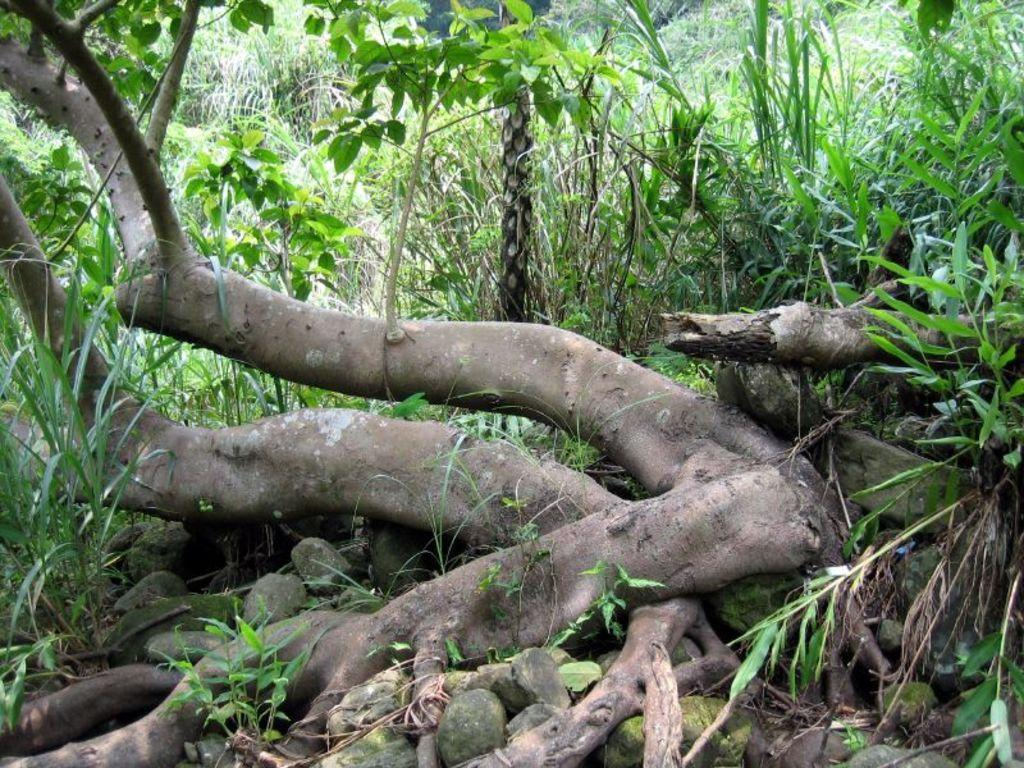What part of a tree can be seen in the image? The trunk of a tree is visible in the image. What other types of vegetation are present in the image? There are plants and trees in the image. What type of leg can be seen in the image? There are no legs visible in the image; it features vegetation such as a tree trunk, plants, and trees. What sense can be experienced by observing the image? The image is visual, so the sense of sight is experienced by observing it. 